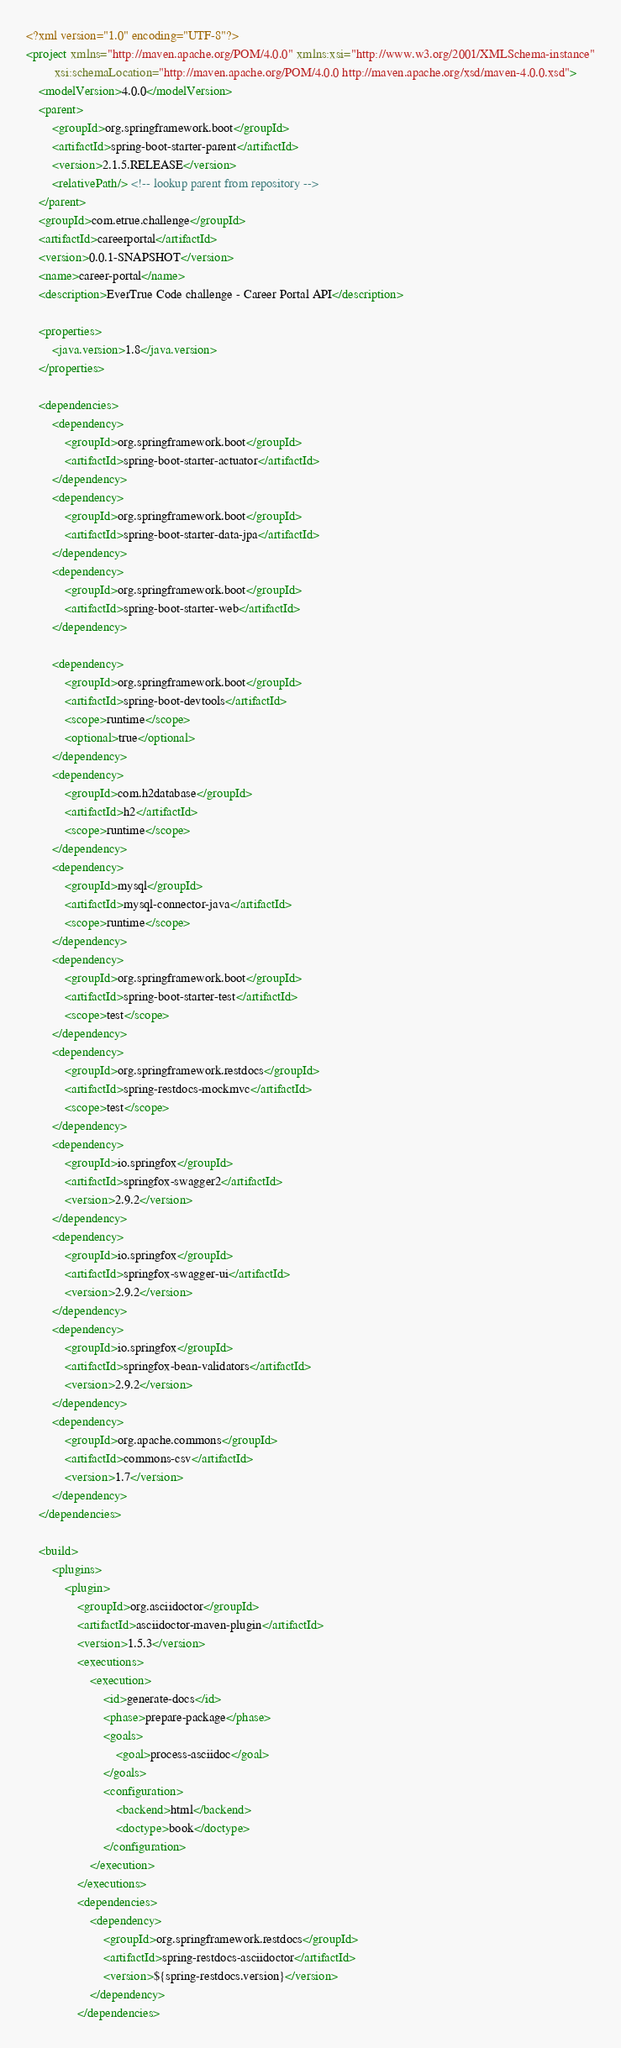Convert code to text. <code><loc_0><loc_0><loc_500><loc_500><_XML_><?xml version="1.0" encoding="UTF-8"?>
<project xmlns="http://maven.apache.org/POM/4.0.0" xmlns:xsi="http://www.w3.org/2001/XMLSchema-instance"
         xsi:schemaLocation="http://maven.apache.org/POM/4.0.0 http://maven.apache.org/xsd/maven-4.0.0.xsd">
    <modelVersion>4.0.0</modelVersion>
    <parent>
        <groupId>org.springframework.boot</groupId>
        <artifactId>spring-boot-starter-parent</artifactId>
        <version>2.1.5.RELEASE</version>
        <relativePath/> <!-- lookup parent from repository -->
    </parent>
    <groupId>com.etrue.challenge</groupId>
    <artifactId>careerportal</artifactId>
    <version>0.0.1-SNAPSHOT</version>
    <name>career-portal</name>
    <description>EverTrue Code challenge - Career Portal API</description>

    <properties>
        <java.version>1.8</java.version>
    </properties>

    <dependencies>
        <dependency>
            <groupId>org.springframework.boot</groupId>
            <artifactId>spring-boot-starter-actuator</artifactId>
        </dependency>
        <dependency>
            <groupId>org.springframework.boot</groupId>
            <artifactId>spring-boot-starter-data-jpa</artifactId>
        </dependency>
        <dependency>
            <groupId>org.springframework.boot</groupId>
            <artifactId>spring-boot-starter-web</artifactId>
        </dependency>

        <dependency>
            <groupId>org.springframework.boot</groupId>
            <artifactId>spring-boot-devtools</artifactId>
            <scope>runtime</scope>
            <optional>true</optional>
        </dependency>
        <dependency>
            <groupId>com.h2database</groupId>
            <artifactId>h2</artifactId>
            <scope>runtime</scope>
        </dependency>
        <dependency>
            <groupId>mysql</groupId>
            <artifactId>mysql-connector-java</artifactId>
            <scope>runtime</scope>
        </dependency>
        <dependency>
            <groupId>org.springframework.boot</groupId>
            <artifactId>spring-boot-starter-test</artifactId>
            <scope>test</scope>
        </dependency>
        <dependency>
            <groupId>org.springframework.restdocs</groupId>
            <artifactId>spring-restdocs-mockmvc</artifactId>
            <scope>test</scope>
        </dependency>
        <dependency>
            <groupId>io.springfox</groupId>
            <artifactId>springfox-swagger2</artifactId>
            <version>2.9.2</version>
        </dependency>
        <dependency>
            <groupId>io.springfox</groupId>
            <artifactId>springfox-swagger-ui</artifactId>
            <version>2.9.2</version>
        </dependency>
        <dependency>
            <groupId>io.springfox</groupId>
            <artifactId>springfox-bean-validators</artifactId>
            <version>2.9.2</version>
        </dependency>
        <dependency>
            <groupId>org.apache.commons</groupId>
            <artifactId>commons-csv</artifactId>
            <version>1.7</version>
        </dependency>
    </dependencies>

    <build>
        <plugins>
            <plugin>
                <groupId>org.asciidoctor</groupId>
                <artifactId>asciidoctor-maven-plugin</artifactId>
                <version>1.5.3</version>
                <executions>
                    <execution>
                        <id>generate-docs</id>
                        <phase>prepare-package</phase>
                        <goals>
                            <goal>process-asciidoc</goal>
                        </goals>
                        <configuration>
                            <backend>html</backend>
                            <doctype>book</doctype>
                        </configuration>
                    </execution>
                </executions>
                <dependencies>
                    <dependency>
                        <groupId>org.springframework.restdocs</groupId>
                        <artifactId>spring-restdocs-asciidoctor</artifactId>
                        <version>${spring-restdocs.version}</version>
                    </dependency>
                </dependencies></code> 